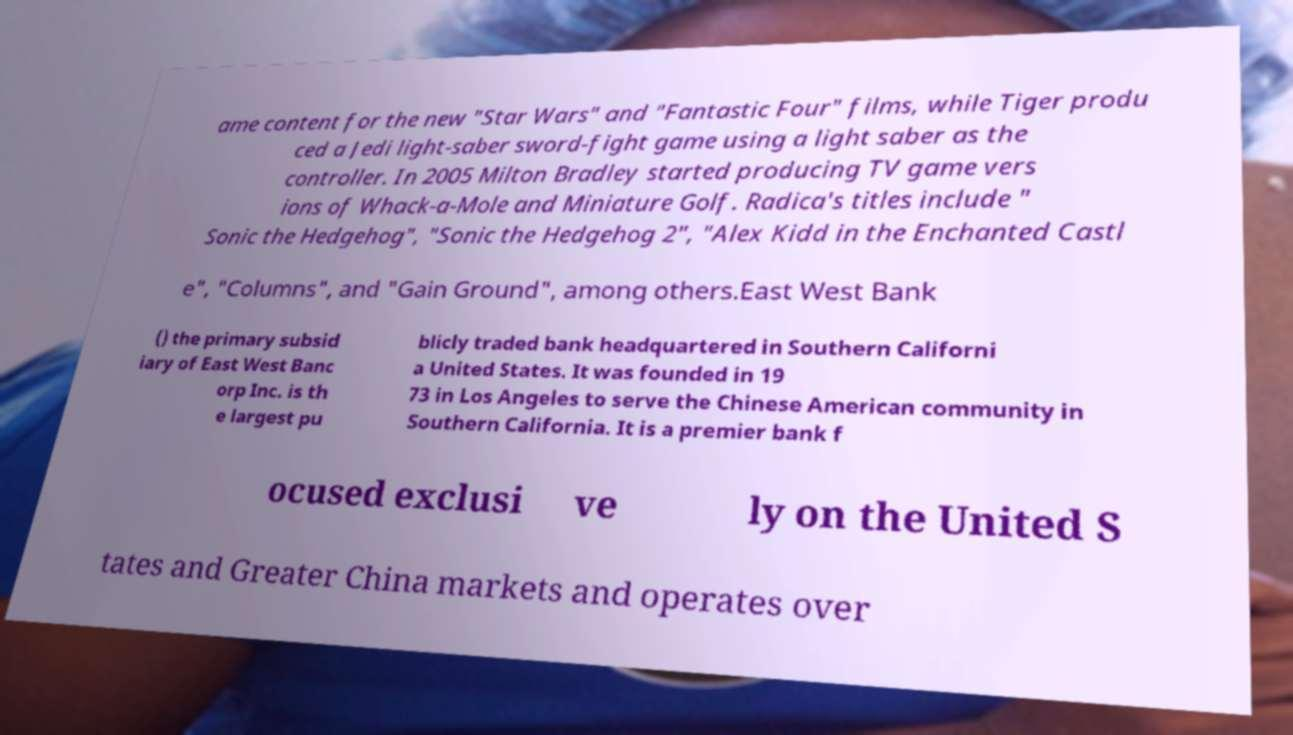There's text embedded in this image that I need extracted. Can you transcribe it verbatim? ame content for the new "Star Wars" and "Fantastic Four" films, while Tiger produ ced a Jedi light-saber sword-fight game using a light saber as the controller. In 2005 Milton Bradley started producing TV game vers ions of Whack-a-Mole and Miniature Golf. Radica's titles include " Sonic the Hedgehog", "Sonic the Hedgehog 2", "Alex Kidd in the Enchanted Castl e", "Columns", and "Gain Ground", among others.East West Bank () the primary subsid iary of East West Banc orp Inc. is th e largest pu blicly traded bank headquartered in Southern Californi a United States. It was founded in 19 73 in Los Angeles to serve the Chinese American community in Southern California. It is a premier bank f ocused exclusi ve ly on the United S tates and Greater China markets and operates over 